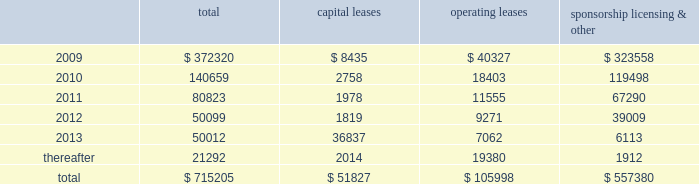Mastercard incorporated notes to consolidated financial statements 2014 ( continued ) ( in thousands , except percent and per share data ) note 17 .
Commitments at december 31 , 2008 , the company had the following future minimum payments due under non-cancelable agreements : capital leases operating leases sponsorship , licensing & .
Included in the table above are capital leases with imputed interest expense of $ 9483 and a net present value of minimum lease payments of $ 42343 .
In addition , at december 31 , 2008 , $ 92300 of the future minimum payments in the table above for leases , sponsorship , licensing and other agreements was accrued .
Consolidated rental expense for the company 2019s office space , which is recognized on a straight line basis over the life of the lease , was approximately $ 42905 , $ 35614 and $ 31467 for the years ended december 31 , 2008 , 2007 and 2006 , respectively .
Consolidated lease expense for automobiles , computer equipment and office equipment was $ 7694 , $ 7679 and $ 8419 for the years ended december 31 , 2008 , 2007 and 2006 , respectively .
In january 2003 , mastercard purchased a building in kansas city , missouri for approximately $ 23572 .
The building is a co-processing data center which replaced a back-up data center in lake success , new york .
During 2003 , mastercard entered into agreements with the city of kansas city for ( i ) the sale-leaseback of the building and related equipment which totaled $ 36382 and ( ii ) the purchase of municipal bonds for the same amount which have been classified as municipal bonds held-to-maturity .
The agreements enabled mastercard to secure state and local financial benefits .
No gain or loss was recorded in connection with the agreements .
The leaseback has been accounted for as a capital lease as the agreement contains a bargain purchase option at the end of the ten-year lease term on april 1 , 2013 .
The building and related equipment are being depreciated over their estimated economic life in accordance with the company 2019s policy .
Rent of $ 1819 is due annually and is equal to the interest due on the municipal bonds .
The future minimum lease payments are $ 45781 and are included in the table above .
A portion of the building was subleased to the original building owner for a five-year term with a renewal option .
As of december 31 , 2008 , the future minimum sublease rental income is $ 4416 .
Note 18 .
Obligations under litigation settlements on october 27 , 2008 , mastercard and visa inc .
( 201cvisa 201d ) entered into a settlement agreement ( the 201cdiscover settlement 201d ) with discover financial services , inc .
( 201cdiscover 201d ) relating to the u.s .
Federal antitrust litigation amongst the parties .
The discover settlement ended all litigation between the parties for a total of $ 2750000 .
In july 2008 , mastercard and visa had entered into a judgment sharing agreement that allocated responsibility for any judgment or settlement of the discover action between the parties .
Accordingly , the mastercard share of the discover settlement was $ 862500 , which was paid to discover in november 2008 .
In addition , in connection with the discover settlement , morgan stanley , discover 2019s former parent company , paid mastercard $ 35000 in november 2008 , pursuant to a separate agreement .
The net impact of $ 827500 is included in litigation settlements for the year ended december 31 , 2008. .
What was the average consolidated rental expense from 2006 to 2008? 
Rationale: the average consolidated rental expense from 2006 to 2008 was 36662
Computations: (((31467 + (42905 + 35614)) + 3) / 2)
Answer: 54994.5. 